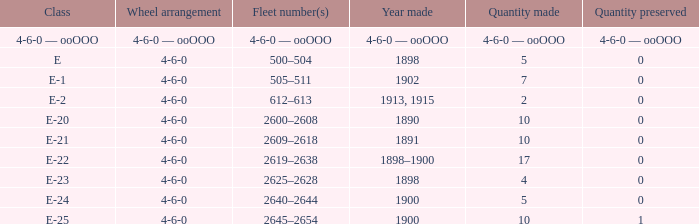What is the wheel arrangement made in 1890? 4-6-0. 